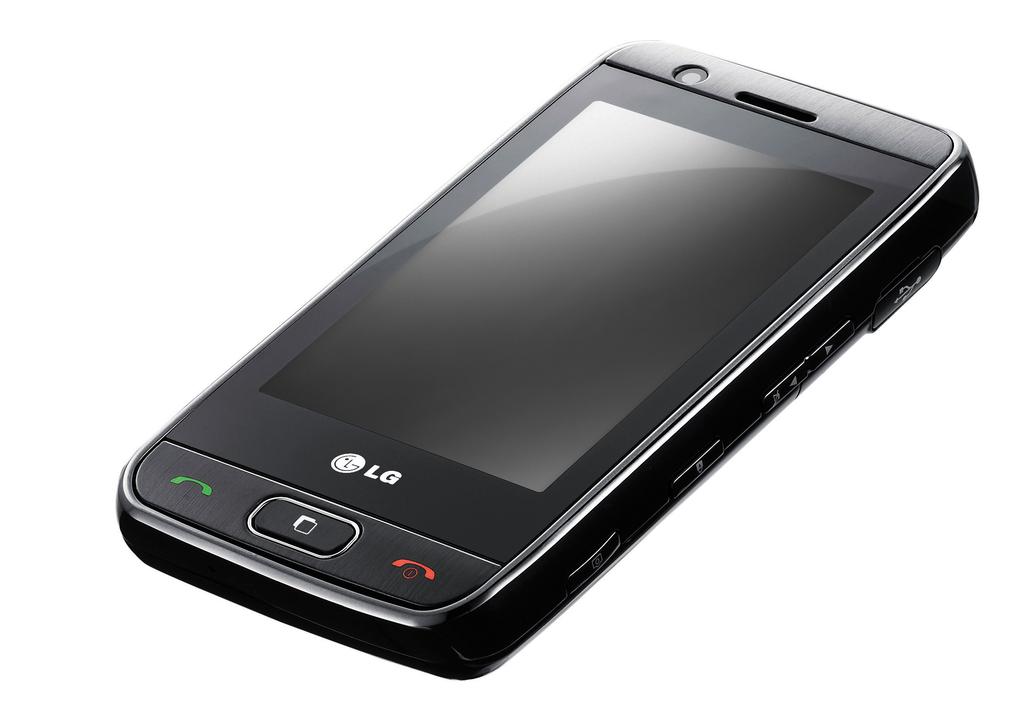Is this an lg phone?
Your answer should be compact. Yes. 